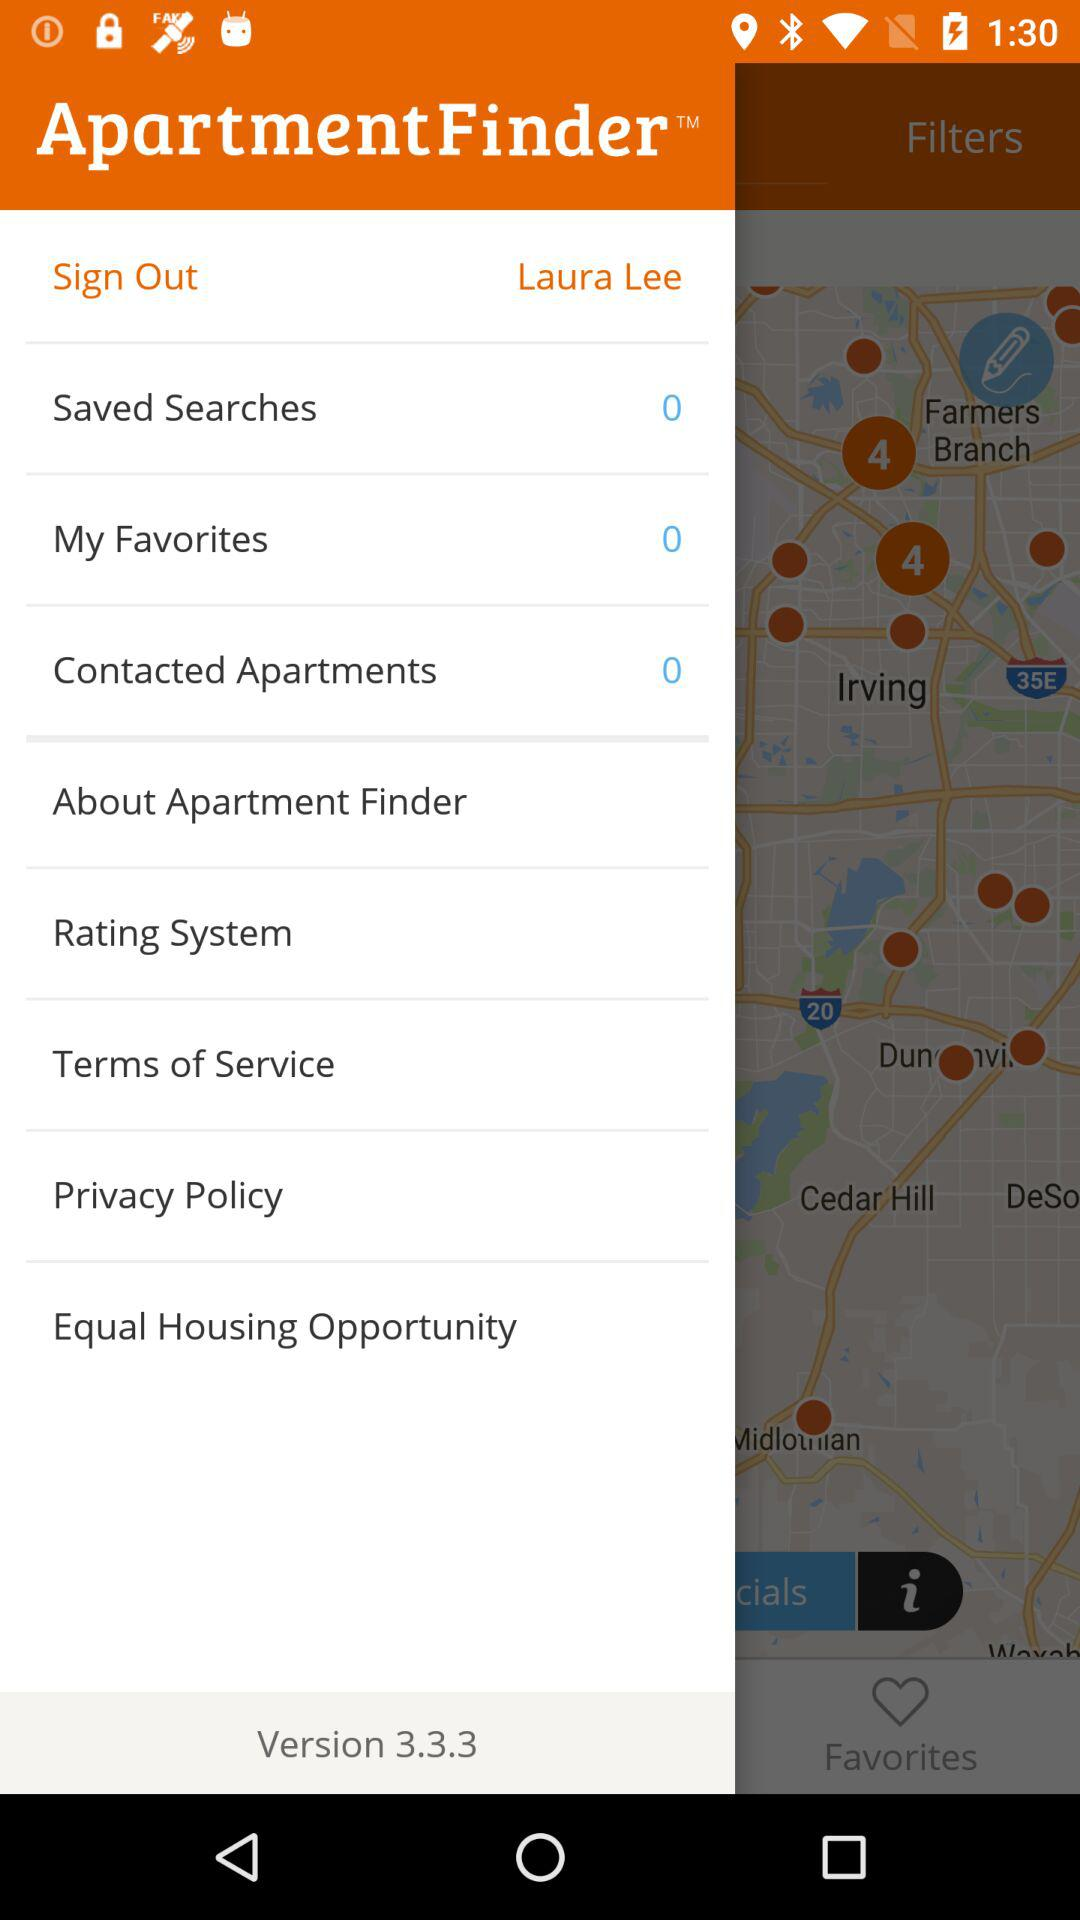What is the version of Apartment Finder? The version of Apartment Finder is 3.3.3. 